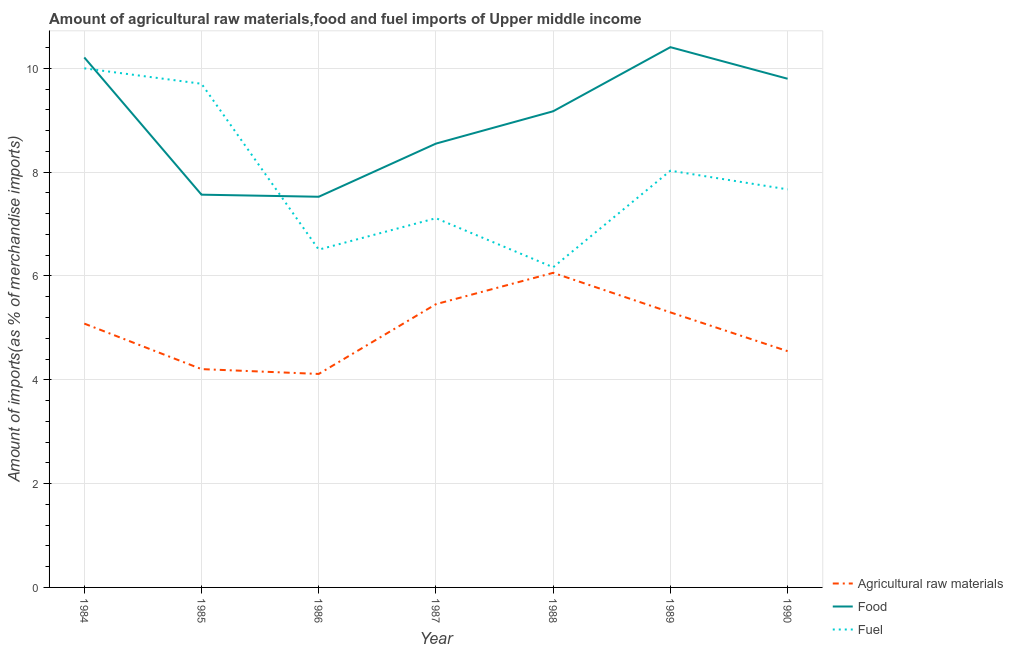Does the line corresponding to percentage of food imports intersect with the line corresponding to percentage of fuel imports?
Offer a terse response. Yes. What is the percentage of fuel imports in 1985?
Offer a terse response. 9.7. Across all years, what is the maximum percentage of food imports?
Offer a terse response. 10.41. Across all years, what is the minimum percentage of raw materials imports?
Your answer should be compact. 4.11. What is the total percentage of fuel imports in the graph?
Provide a short and direct response. 55.19. What is the difference between the percentage of raw materials imports in 1985 and that in 1990?
Give a very brief answer. -0.35. What is the difference between the percentage of fuel imports in 1988 and the percentage of raw materials imports in 1987?
Offer a very short reply. 0.71. What is the average percentage of food imports per year?
Your answer should be compact. 9.03. In the year 1990, what is the difference between the percentage of fuel imports and percentage of raw materials imports?
Your answer should be compact. 3.12. What is the ratio of the percentage of food imports in 1984 to that in 1986?
Ensure brevity in your answer.  1.36. What is the difference between the highest and the second highest percentage of fuel imports?
Offer a very short reply. 0.3. What is the difference between the highest and the lowest percentage of raw materials imports?
Your answer should be very brief. 1.95. Is the sum of the percentage of food imports in 1984 and 1988 greater than the maximum percentage of raw materials imports across all years?
Provide a short and direct response. Yes. Is it the case that in every year, the sum of the percentage of raw materials imports and percentage of food imports is greater than the percentage of fuel imports?
Keep it short and to the point. Yes. Is the percentage of raw materials imports strictly less than the percentage of fuel imports over the years?
Give a very brief answer. Yes. How many lines are there?
Give a very brief answer. 3. Where does the legend appear in the graph?
Provide a short and direct response. Bottom right. What is the title of the graph?
Your answer should be very brief. Amount of agricultural raw materials,food and fuel imports of Upper middle income. What is the label or title of the X-axis?
Keep it short and to the point. Year. What is the label or title of the Y-axis?
Your answer should be compact. Amount of imports(as % of merchandise imports). What is the Amount of imports(as % of merchandise imports) of Agricultural raw materials in 1984?
Give a very brief answer. 5.08. What is the Amount of imports(as % of merchandise imports) of Food in 1984?
Offer a terse response. 10.21. What is the Amount of imports(as % of merchandise imports) in Fuel in 1984?
Give a very brief answer. 10. What is the Amount of imports(as % of merchandise imports) in Agricultural raw materials in 1985?
Your answer should be compact. 4.21. What is the Amount of imports(as % of merchandise imports) in Food in 1985?
Give a very brief answer. 7.57. What is the Amount of imports(as % of merchandise imports) of Fuel in 1985?
Your answer should be compact. 9.7. What is the Amount of imports(as % of merchandise imports) in Agricultural raw materials in 1986?
Provide a succinct answer. 4.11. What is the Amount of imports(as % of merchandise imports) of Food in 1986?
Your response must be concise. 7.53. What is the Amount of imports(as % of merchandise imports) of Fuel in 1986?
Ensure brevity in your answer.  6.51. What is the Amount of imports(as % of merchandise imports) of Agricultural raw materials in 1987?
Keep it short and to the point. 5.46. What is the Amount of imports(as % of merchandise imports) in Food in 1987?
Ensure brevity in your answer.  8.55. What is the Amount of imports(as % of merchandise imports) of Fuel in 1987?
Your answer should be compact. 7.11. What is the Amount of imports(as % of merchandise imports) of Agricultural raw materials in 1988?
Your answer should be compact. 6.06. What is the Amount of imports(as % of merchandise imports) of Food in 1988?
Your answer should be very brief. 9.17. What is the Amount of imports(as % of merchandise imports) in Fuel in 1988?
Provide a succinct answer. 6.17. What is the Amount of imports(as % of merchandise imports) in Agricultural raw materials in 1989?
Your response must be concise. 5.3. What is the Amount of imports(as % of merchandise imports) in Food in 1989?
Provide a succinct answer. 10.41. What is the Amount of imports(as % of merchandise imports) of Fuel in 1989?
Your response must be concise. 8.03. What is the Amount of imports(as % of merchandise imports) in Agricultural raw materials in 1990?
Offer a terse response. 4.55. What is the Amount of imports(as % of merchandise imports) of Food in 1990?
Offer a terse response. 9.8. What is the Amount of imports(as % of merchandise imports) of Fuel in 1990?
Your response must be concise. 7.67. Across all years, what is the maximum Amount of imports(as % of merchandise imports) of Agricultural raw materials?
Provide a short and direct response. 6.06. Across all years, what is the maximum Amount of imports(as % of merchandise imports) in Food?
Your answer should be compact. 10.41. Across all years, what is the maximum Amount of imports(as % of merchandise imports) in Fuel?
Offer a very short reply. 10. Across all years, what is the minimum Amount of imports(as % of merchandise imports) in Agricultural raw materials?
Your response must be concise. 4.11. Across all years, what is the minimum Amount of imports(as % of merchandise imports) of Food?
Give a very brief answer. 7.53. Across all years, what is the minimum Amount of imports(as % of merchandise imports) in Fuel?
Give a very brief answer. 6.17. What is the total Amount of imports(as % of merchandise imports) of Agricultural raw materials in the graph?
Give a very brief answer. 34.77. What is the total Amount of imports(as % of merchandise imports) in Food in the graph?
Your answer should be compact. 63.23. What is the total Amount of imports(as % of merchandise imports) of Fuel in the graph?
Make the answer very short. 55.19. What is the difference between the Amount of imports(as % of merchandise imports) in Agricultural raw materials in 1984 and that in 1985?
Give a very brief answer. 0.88. What is the difference between the Amount of imports(as % of merchandise imports) of Food in 1984 and that in 1985?
Offer a terse response. 2.64. What is the difference between the Amount of imports(as % of merchandise imports) in Fuel in 1984 and that in 1985?
Provide a succinct answer. 0.3. What is the difference between the Amount of imports(as % of merchandise imports) in Agricultural raw materials in 1984 and that in 1986?
Your answer should be compact. 0.97. What is the difference between the Amount of imports(as % of merchandise imports) of Food in 1984 and that in 1986?
Provide a succinct answer. 2.68. What is the difference between the Amount of imports(as % of merchandise imports) in Fuel in 1984 and that in 1986?
Make the answer very short. 3.49. What is the difference between the Amount of imports(as % of merchandise imports) of Agricultural raw materials in 1984 and that in 1987?
Keep it short and to the point. -0.37. What is the difference between the Amount of imports(as % of merchandise imports) of Food in 1984 and that in 1987?
Keep it short and to the point. 1.66. What is the difference between the Amount of imports(as % of merchandise imports) of Fuel in 1984 and that in 1987?
Ensure brevity in your answer.  2.89. What is the difference between the Amount of imports(as % of merchandise imports) in Agricultural raw materials in 1984 and that in 1988?
Keep it short and to the point. -0.98. What is the difference between the Amount of imports(as % of merchandise imports) of Food in 1984 and that in 1988?
Provide a succinct answer. 1.04. What is the difference between the Amount of imports(as % of merchandise imports) of Fuel in 1984 and that in 1988?
Provide a short and direct response. 3.83. What is the difference between the Amount of imports(as % of merchandise imports) of Agricultural raw materials in 1984 and that in 1989?
Give a very brief answer. -0.22. What is the difference between the Amount of imports(as % of merchandise imports) in Food in 1984 and that in 1989?
Give a very brief answer. -0.2. What is the difference between the Amount of imports(as % of merchandise imports) in Fuel in 1984 and that in 1989?
Your answer should be compact. 1.97. What is the difference between the Amount of imports(as % of merchandise imports) of Agricultural raw materials in 1984 and that in 1990?
Your answer should be compact. 0.53. What is the difference between the Amount of imports(as % of merchandise imports) of Food in 1984 and that in 1990?
Ensure brevity in your answer.  0.41. What is the difference between the Amount of imports(as % of merchandise imports) in Fuel in 1984 and that in 1990?
Offer a terse response. 2.33. What is the difference between the Amount of imports(as % of merchandise imports) in Agricultural raw materials in 1985 and that in 1986?
Give a very brief answer. 0.09. What is the difference between the Amount of imports(as % of merchandise imports) of Food in 1985 and that in 1986?
Your response must be concise. 0.04. What is the difference between the Amount of imports(as % of merchandise imports) in Fuel in 1985 and that in 1986?
Provide a short and direct response. 3.2. What is the difference between the Amount of imports(as % of merchandise imports) in Agricultural raw materials in 1985 and that in 1987?
Make the answer very short. -1.25. What is the difference between the Amount of imports(as % of merchandise imports) in Food in 1985 and that in 1987?
Keep it short and to the point. -0.98. What is the difference between the Amount of imports(as % of merchandise imports) of Fuel in 1985 and that in 1987?
Provide a short and direct response. 2.59. What is the difference between the Amount of imports(as % of merchandise imports) of Agricultural raw materials in 1985 and that in 1988?
Your response must be concise. -1.85. What is the difference between the Amount of imports(as % of merchandise imports) of Food in 1985 and that in 1988?
Your answer should be compact. -1.61. What is the difference between the Amount of imports(as % of merchandise imports) in Fuel in 1985 and that in 1988?
Provide a short and direct response. 3.54. What is the difference between the Amount of imports(as % of merchandise imports) of Agricultural raw materials in 1985 and that in 1989?
Give a very brief answer. -1.09. What is the difference between the Amount of imports(as % of merchandise imports) in Food in 1985 and that in 1989?
Provide a short and direct response. -2.84. What is the difference between the Amount of imports(as % of merchandise imports) of Fuel in 1985 and that in 1989?
Give a very brief answer. 1.67. What is the difference between the Amount of imports(as % of merchandise imports) of Agricultural raw materials in 1985 and that in 1990?
Offer a very short reply. -0.35. What is the difference between the Amount of imports(as % of merchandise imports) of Food in 1985 and that in 1990?
Provide a succinct answer. -2.23. What is the difference between the Amount of imports(as % of merchandise imports) in Fuel in 1985 and that in 1990?
Make the answer very short. 2.03. What is the difference between the Amount of imports(as % of merchandise imports) of Agricultural raw materials in 1986 and that in 1987?
Keep it short and to the point. -1.34. What is the difference between the Amount of imports(as % of merchandise imports) in Food in 1986 and that in 1987?
Keep it short and to the point. -1.02. What is the difference between the Amount of imports(as % of merchandise imports) of Fuel in 1986 and that in 1987?
Keep it short and to the point. -0.61. What is the difference between the Amount of imports(as % of merchandise imports) of Agricultural raw materials in 1986 and that in 1988?
Your response must be concise. -1.95. What is the difference between the Amount of imports(as % of merchandise imports) in Food in 1986 and that in 1988?
Provide a succinct answer. -1.65. What is the difference between the Amount of imports(as % of merchandise imports) in Fuel in 1986 and that in 1988?
Offer a terse response. 0.34. What is the difference between the Amount of imports(as % of merchandise imports) in Agricultural raw materials in 1986 and that in 1989?
Your answer should be compact. -1.19. What is the difference between the Amount of imports(as % of merchandise imports) of Food in 1986 and that in 1989?
Provide a succinct answer. -2.88. What is the difference between the Amount of imports(as % of merchandise imports) in Fuel in 1986 and that in 1989?
Your response must be concise. -1.52. What is the difference between the Amount of imports(as % of merchandise imports) in Agricultural raw materials in 1986 and that in 1990?
Provide a succinct answer. -0.44. What is the difference between the Amount of imports(as % of merchandise imports) in Food in 1986 and that in 1990?
Your answer should be very brief. -2.27. What is the difference between the Amount of imports(as % of merchandise imports) of Fuel in 1986 and that in 1990?
Provide a succinct answer. -1.16. What is the difference between the Amount of imports(as % of merchandise imports) of Agricultural raw materials in 1987 and that in 1988?
Provide a short and direct response. -0.6. What is the difference between the Amount of imports(as % of merchandise imports) in Food in 1987 and that in 1988?
Give a very brief answer. -0.62. What is the difference between the Amount of imports(as % of merchandise imports) in Fuel in 1987 and that in 1988?
Your answer should be very brief. 0.95. What is the difference between the Amount of imports(as % of merchandise imports) in Agricultural raw materials in 1987 and that in 1989?
Make the answer very short. 0.16. What is the difference between the Amount of imports(as % of merchandise imports) of Food in 1987 and that in 1989?
Keep it short and to the point. -1.86. What is the difference between the Amount of imports(as % of merchandise imports) in Fuel in 1987 and that in 1989?
Provide a succinct answer. -0.92. What is the difference between the Amount of imports(as % of merchandise imports) of Agricultural raw materials in 1987 and that in 1990?
Your answer should be compact. 0.91. What is the difference between the Amount of imports(as % of merchandise imports) in Food in 1987 and that in 1990?
Provide a succinct answer. -1.25. What is the difference between the Amount of imports(as % of merchandise imports) of Fuel in 1987 and that in 1990?
Provide a short and direct response. -0.56. What is the difference between the Amount of imports(as % of merchandise imports) in Agricultural raw materials in 1988 and that in 1989?
Your answer should be compact. 0.76. What is the difference between the Amount of imports(as % of merchandise imports) of Food in 1988 and that in 1989?
Provide a short and direct response. -1.23. What is the difference between the Amount of imports(as % of merchandise imports) in Fuel in 1988 and that in 1989?
Your answer should be very brief. -1.86. What is the difference between the Amount of imports(as % of merchandise imports) of Agricultural raw materials in 1988 and that in 1990?
Offer a terse response. 1.51. What is the difference between the Amount of imports(as % of merchandise imports) in Food in 1988 and that in 1990?
Offer a very short reply. -0.63. What is the difference between the Amount of imports(as % of merchandise imports) of Fuel in 1988 and that in 1990?
Your response must be concise. -1.5. What is the difference between the Amount of imports(as % of merchandise imports) of Agricultural raw materials in 1989 and that in 1990?
Keep it short and to the point. 0.75. What is the difference between the Amount of imports(as % of merchandise imports) in Food in 1989 and that in 1990?
Give a very brief answer. 0.61. What is the difference between the Amount of imports(as % of merchandise imports) in Fuel in 1989 and that in 1990?
Provide a succinct answer. 0.36. What is the difference between the Amount of imports(as % of merchandise imports) in Agricultural raw materials in 1984 and the Amount of imports(as % of merchandise imports) in Food in 1985?
Keep it short and to the point. -2.48. What is the difference between the Amount of imports(as % of merchandise imports) in Agricultural raw materials in 1984 and the Amount of imports(as % of merchandise imports) in Fuel in 1985?
Provide a short and direct response. -4.62. What is the difference between the Amount of imports(as % of merchandise imports) of Food in 1984 and the Amount of imports(as % of merchandise imports) of Fuel in 1985?
Provide a succinct answer. 0.51. What is the difference between the Amount of imports(as % of merchandise imports) in Agricultural raw materials in 1984 and the Amount of imports(as % of merchandise imports) in Food in 1986?
Make the answer very short. -2.44. What is the difference between the Amount of imports(as % of merchandise imports) in Agricultural raw materials in 1984 and the Amount of imports(as % of merchandise imports) in Fuel in 1986?
Offer a very short reply. -1.42. What is the difference between the Amount of imports(as % of merchandise imports) in Food in 1984 and the Amount of imports(as % of merchandise imports) in Fuel in 1986?
Keep it short and to the point. 3.7. What is the difference between the Amount of imports(as % of merchandise imports) in Agricultural raw materials in 1984 and the Amount of imports(as % of merchandise imports) in Food in 1987?
Provide a succinct answer. -3.47. What is the difference between the Amount of imports(as % of merchandise imports) of Agricultural raw materials in 1984 and the Amount of imports(as % of merchandise imports) of Fuel in 1987?
Ensure brevity in your answer.  -2.03. What is the difference between the Amount of imports(as % of merchandise imports) of Food in 1984 and the Amount of imports(as % of merchandise imports) of Fuel in 1987?
Offer a terse response. 3.1. What is the difference between the Amount of imports(as % of merchandise imports) of Agricultural raw materials in 1984 and the Amount of imports(as % of merchandise imports) of Food in 1988?
Provide a succinct answer. -4.09. What is the difference between the Amount of imports(as % of merchandise imports) of Agricultural raw materials in 1984 and the Amount of imports(as % of merchandise imports) of Fuel in 1988?
Give a very brief answer. -1.08. What is the difference between the Amount of imports(as % of merchandise imports) of Food in 1984 and the Amount of imports(as % of merchandise imports) of Fuel in 1988?
Offer a terse response. 4.04. What is the difference between the Amount of imports(as % of merchandise imports) of Agricultural raw materials in 1984 and the Amount of imports(as % of merchandise imports) of Food in 1989?
Your response must be concise. -5.33. What is the difference between the Amount of imports(as % of merchandise imports) of Agricultural raw materials in 1984 and the Amount of imports(as % of merchandise imports) of Fuel in 1989?
Offer a very short reply. -2.95. What is the difference between the Amount of imports(as % of merchandise imports) in Food in 1984 and the Amount of imports(as % of merchandise imports) in Fuel in 1989?
Your response must be concise. 2.18. What is the difference between the Amount of imports(as % of merchandise imports) in Agricultural raw materials in 1984 and the Amount of imports(as % of merchandise imports) in Food in 1990?
Keep it short and to the point. -4.72. What is the difference between the Amount of imports(as % of merchandise imports) in Agricultural raw materials in 1984 and the Amount of imports(as % of merchandise imports) in Fuel in 1990?
Offer a terse response. -2.59. What is the difference between the Amount of imports(as % of merchandise imports) in Food in 1984 and the Amount of imports(as % of merchandise imports) in Fuel in 1990?
Offer a terse response. 2.54. What is the difference between the Amount of imports(as % of merchandise imports) in Agricultural raw materials in 1985 and the Amount of imports(as % of merchandise imports) in Food in 1986?
Offer a very short reply. -3.32. What is the difference between the Amount of imports(as % of merchandise imports) of Agricultural raw materials in 1985 and the Amount of imports(as % of merchandise imports) of Fuel in 1986?
Keep it short and to the point. -2.3. What is the difference between the Amount of imports(as % of merchandise imports) of Food in 1985 and the Amount of imports(as % of merchandise imports) of Fuel in 1986?
Ensure brevity in your answer.  1.06. What is the difference between the Amount of imports(as % of merchandise imports) of Agricultural raw materials in 1985 and the Amount of imports(as % of merchandise imports) of Food in 1987?
Offer a terse response. -4.34. What is the difference between the Amount of imports(as % of merchandise imports) in Agricultural raw materials in 1985 and the Amount of imports(as % of merchandise imports) in Fuel in 1987?
Give a very brief answer. -2.91. What is the difference between the Amount of imports(as % of merchandise imports) in Food in 1985 and the Amount of imports(as % of merchandise imports) in Fuel in 1987?
Provide a succinct answer. 0.45. What is the difference between the Amount of imports(as % of merchandise imports) of Agricultural raw materials in 1985 and the Amount of imports(as % of merchandise imports) of Food in 1988?
Give a very brief answer. -4.97. What is the difference between the Amount of imports(as % of merchandise imports) in Agricultural raw materials in 1985 and the Amount of imports(as % of merchandise imports) in Fuel in 1988?
Ensure brevity in your answer.  -1.96. What is the difference between the Amount of imports(as % of merchandise imports) in Food in 1985 and the Amount of imports(as % of merchandise imports) in Fuel in 1988?
Your answer should be very brief. 1.4. What is the difference between the Amount of imports(as % of merchandise imports) of Agricultural raw materials in 1985 and the Amount of imports(as % of merchandise imports) of Food in 1989?
Give a very brief answer. -6.2. What is the difference between the Amount of imports(as % of merchandise imports) in Agricultural raw materials in 1985 and the Amount of imports(as % of merchandise imports) in Fuel in 1989?
Keep it short and to the point. -3.82. What is the difference between the Amount of imports(as % of merchandise imports) of Food in 1985 and the Amount of imports(as % of merchandise imports) of Fuel in 1989?
Offer a terse response. -0.46. What is the difference between the Amount of imports(as % of merchandise imports) of Agricultural raw materials in 1985 and the Amount of imports(as % of merchandise imports) of Food in 1990?
Give a very brief answer. -5.59. What is the difference between the Amount of imports(as % of merchandise imports) in Agricultural raw materials in 1985 and the Amount of imports(as % of merchandise imports) in Fuel in 1990?
Ensure brevity in your answer.  -3.46. What is the difference between the Amount of imports(as % of merchandise imports) of Food in 1985 and the Amount of imports(as % of merchandise imports) of Fuel in 1990?
Provide a short and direct response. -0.1. What is the difference between the Amount of imports(as % of merchandise imports) in Agricultural raw materials in 1986 and the Amount of imports(as % of merchandise imports) in Food in 1987?
Provide a succinct answer. -4.44. What is the difference between the Amount of imports(as % of merchandise imports) of Agricultural raw materials in 1986 and the Amount of imports(as % of merchandise imports) of Fuel in 1987?
Make the answer very short. -3. What is the difference between the Amount of imports(as % of merchandise imports) in Food in 1986 and the Amount of imports(as % of merchandise imports) in Fuel in 1987?
Ensure brevity in your answer.  0.41. What is the difference between the Amount of imports(as % of merchandise imports) of Agricultural raw materials in 1986 and the Amount of imports(as % of merchandise imports) of Food in 1988?
Your answer should be compact. -5.06. What is the difference between the Amount of imports(as % of merchandise imports) of Agricultural raw materials in 1986 and the Amount of imports(as % of merchandise imports) of Fuel in 1988?
Your response must be concise. -2.05. What is the difference between the Amount of imports(as % of merchandise imports) of Food in 1986 and the Amount of imports(as % of merchandise imports) of Fuel in 1988?
Keep it short and to the point. 1.36. What is the difference between the Amount of imports(as % of merchandise imports) of Agricultural raw materials in 1986 and the Amount of imports(as % of merchandise imports) of Food in 1989?
Make the answer very short. -6.3. What is the difference between the Amount of imports(as % of merchandise imports) in Agricultural raw materials in 1986 and the Amount of imports(as % of merchandise imports) in Fuel in 1989?
Provide a succinct answer. -3.92. What is the difference between the Amount of imports(as % of merchandise imports) of Food in 1986 and the Amount of imports(as % of merchandise imports) of Fuel in 1989?
Make the answer very short. -0.5. What is the difference between the Amount of imports(as % of merchandise imports) in Agricultural raw materials in 1986 and the Amount of imports(as % of merchandise imports) in Food in 1990?
Your answer should be compact. -5.69. What is the difference between the Amount of imports(as % of merchandise imports) of Agricultural raw materials in 1986 and the Amount of imports(as % of merchandise imports) of Fuel in 1990?
Your response must be concise. -3.56. What is the difference between the Amount of imports(as % of merchandise imports) in Food in 1986 and the Amount of imports(as % of merchandise imports) in Fuel in 1990?
Offer a terse response. -0.14. What is the difference between the Amount of imports(as % of merchandise imports) of Agricultural raw materials in 1987 and the Amount of imports(as % of merchandise imports) of Food in 1988?
Ensure brevity in your answer.  -3.72. What is the difference between the Amount of imports(as % of merchandise imports) in Agricultural raw materials in 1987 and the Amount of imports(as % of merchandise imports) in Fuel in 1988?
Provide a succinct answer. -0.71. What is the difference between the Amount of imports(as % of merchandise imports) in Food in 1987 and the Amount of imports(as % of merchandise imports) in Fuel in 1988?
Give a very brief answer. 2.38. What is the difference between the Amount of imports(as % of merchandise imports) of Agricultural raw materials in 1987 and the Amount of imports(as % of merchandise imports) of Food in 1989?
Ensure brevity in your answer.  -4.95. What is the difference between the Amount of imports(as % of merchandise imports) in Agricultural raw materials in 1987 and the Amount of imports(as % of merchandise imports) in Fuel in 1989?
Offer a terse response. -2.57. What is the difference between the Amount of imports(as % of merchandise imports) of Food in 1987 and the Amount of imports(as % of merchandise imports) of Fuel in 1989?
Offer a terse response. 0.52. What is the difference between the Amount of imports(as % of merchandise imports) in Agricultural raw materials in 1987 and the Amount of imports(as % of merchandise imports) in Food in 1990?
Your answer should be compact. -4.34. What is the difference between the Amount of imports(as % of merchandise imports) in Agricultural raw materials in 1987 and the Amount of imports(as % of merchandise imports) in Fuel in 1990?
Offer a very short reply. -2.21. What is the difference between the Amount of imports(as % of merchandise imports) of Food in 1987 and the Amount of imports(as % of merchandise imports) of Fuel in 1990?
Make the answer very short. 0.88. What is the difference between the Amount of imports(as % of merchandise imports) in Agricultural raw materials in 1988 and the Amount of imports(as % of merchandise imports) in Food in 1989?
Keep it short and to the point. -4.35. What is the difference between the Amount of imports(as % of merchandise imports) in Agricultural raw materials in 1988 and the Amount of imports(as % of merchandise imports) in Fuel in 1989?
Keep it short and to the point. -1.97. What is the difference between the Amount of imports(as % of merchandise imports) in Food in 1988 and the Amount of imports(as % of merchandise imports) in Fuel in 1989?
Offer a very short reply. 1.14. What is the difference between the Amount of imports(as % of merchandise imports) of Agricultural raw materials in 1988 and the Amount of imports(as % of merchandise imports) of Food in 1990?
Your response must be concise. -3.74. What is the difference between the Amount of imports(as % of merchandise imports) in Agricultural raw materials in 1988 and the Amount of imports(as % of merchandise imports) in Fuel in 1990?
Make the answer very short. -1.61. What is the difference between the Amount of imports(as % of merchandise imports) of Food in 1988 and the Amount of imports(as % of merchandise imports) of Fuel in 1990?
Your answer should be compact. 1.5. What is the difference between the Amount of imports(as % of merchandise imports) in Agricultural raw materials in 1989 and the Amount of imports(as % of merchandise imports) in Food in 1990?
Offer a terse response. -4.5. What is the difference between the Amount of imports(as % of merchandise imports) of Agricultural raw materials in 1989 and the Amount of imports(as % of merchandise imports) of Fuel in 1990?
Offer a terse response. -2.37. What is the difference between the Amount of imports(as % of merchandise imports) of Food in 1989 and the Amount of imports(as % of merchandise imports) of Fuel in 1990?
Your answer should be compact. 2.74. What is the average Amount of imports(as % of merchandise imports) of Agricultural raw materials per year?
Your answer should be very brief. 4.97. What is the average Amount of imports(as % of merchandise imports) of Food per year?
Provide a succinct answer. 9.03. What is the average Amount of imports(as % of merchandise imports) of Fuel per year?
Make the answer very short. 7.88. In the year 1984, what is the difference between the Amount of imports(as % of merchandise imports) of Agricultural raw materials and Amount of imports(as % of merchandise imports) of Food?
Offer a very short reply. -5.13. In the year 1984, what is the difference between the Amount of imports(as % of merchandise imports) of Agricultural raw materials and Amount of imports(as % of merchandise imports) of Fuel?
Offer a very short reply. -4.92. In the year 1984, what is the difference between the Amount of imports(as % of merchandise imports) of Food and Amount of imports(as % of merchandise imports) of Fuel?
Give a very brief answer. 0.21. In the year 1985, what is the difference between the Amount of imports(as % of merchandise imports) in Agricultural raw materials and Amount of imports(as % of merchandise imports) in Food?
Offer a very short reply. -3.36. In the year 1985, what is the difference between the Amount of imports(as % of merchandise imports) of Agricultural raw materials and Amount of imports(as % of merchandise imports) of Fuel?
Give a very brief answer. -5.5. In the year 1985, what is the difference between the Amount of imports(as % of merchandise imports) of Food and Amount of imports(as % of merchandise imports) of Fuel?
Your answer should be very brief. -2.14. In the year 1986, what is the difference between the Amount of imports(as % of merchandise imports) in Agricultural raw materials and Amount of imports(as % of merchandise imports) in Food?
Make the answer very short. -3.41. In the year 1986, what is the difference between the Amount of imports(as % of merchandise imports) in Agricultural raw materials and Amount of imports(as % of merchandise imports) in Fuel?
Offer a very short reply. -2.39. In the year 1986, what is the difference between the Amount of imports(as % of merchandise imports) of Food and Amount of imports(as % of merchandise imports) of Fuel?
Ensure brevity in your answer.  1.02. In the year 1987, what is the difference between the Amount of imports(as % of merchandise imports) of Agricultural raw materials and Amount of imports(as % of merchandise imports) of Food?
Your answer should be very brief. -3.09. In the year 1987, what is the difference between the Amount of imports(as % of merchandise imports) of Agricultural raw materials and Amount of imports(as % of merchandise imports) of Fuel?
Your answer should be very brief. -1.66. In the year 1987, what is the difference between the Amount of imports(as % of merchandise imports) of Food and Amount of imports(as % of merchandise imports) of Fuel?
Keep it short and to the point. 1.44. In the year 1988, what is the difference between the Amount of imports(as % of merchandise imports) in Agricultural raw materials and Amount of imports(as % of merchandise imports) in Food?
Give a very brief answer. -3.11. In the year 1988, what is the difference between the Amount of imports(as % of merchandise imports) of Agricultural raw materials and Amount of imports(as % of merchandise imports) of Fuel?
Give a very brief answer. -0.11. In the year 1988, what is the difference between the Amount of imports(as % of merchandise imports) of Food and Amount of imports(as % of merchandise imports) of Fuel?
Your answer should be very brief. 3.01. In the year 1989, what is the difference between the Amount of imports(as % of merchandise imports) of Agricultural raw materials and Amount of imports(as % of merchandise imports) of Food?
Ensure brevity in your answer.  -5.11. In the year 1989, what is the difference between the Amount of imports(as % of merchandise imports) of Agricultural raw materials and Amount of imports(as % of merchandise imports) of Fuel?
Provide a short and direct response. -2.73. In the year 1989, what is the difference between the Amount of imports(as % of merchandise imports) in Food and Amount of imports(as % of merchandise imports) in Fuel?
Give a very brief answer. 2.38. In the year 1990, what is the difference between the Amount of imports(as % of merchandise imports) of Agricultural raw materials and Amount of imports(as % of merchandise imports) of Food?
Your response must be concise. -5.25. In the year 1990, what is the difference between the Amount of imports(as % of merchandise imports) of Agricultural raw materials and Amount of imports(as % of merchandise imports) of Fuel?
Keep it short and to the point. -3.12. In the year 1990, what is the difference between the Amount of imports(as % of merchandise imports) in Food and Amount of imports(as % of merchandise imports) in Fuel?
Provide a short and direct response. 2.13. What is the ratio of the Amount of imports(as % of merchandise imports) of Agricultural raw materials in 1984 to that in 1985?
Provide a succinct answer. 1.21. What is the ratio of the Amount of imports(as % of merchandise imports) in Food in 1984 to that in 1985?
Offer a terse response. 1.35. What is the ratio of the Amount of imports(as % of merchandise imports) in Fuel in 1984 to that in 1985?
Make the answer very short. 1.03. What is the ratio of the Amount of imports(as % of merchandise imports) of Agricultural raw materials in 1984 to that in 1986?
Your response must be concise. 1.24. What is the ratio of the Amount of imports(as % of merchandise imports) of Food in 1984 to that in 1986?
Offer a very short reply. 1.36. What is the ratio of the Amount of imports(as % of merchandise imports) of Fuel in 1984 to that in 1986?
Your response must be concise. 1.54. What is the ratio of the Amount of imports(as % of merchandise imports) in Agricultural raw materials in 1984 to that in 1987?
Provide a succinct answer. 0.93. What is the ratio of the Amount of imports(as % of merchandise imports) in Food in 1984 to that in 1987?
Your answer should be compact. 1.19. What is the ratio of the Amount of imports(as % of merchandise imports) in Fuel in 1984 to that in 1987?
Ensure brevity in your answer.  1.41. What is the ratio of the Amount of imports(as % of merchandise imports) of Agricultural raw materials in 1984 to that in 1988?
Offer a very short reply. 0.84. What is the ratio of the Amount of imports(as % of merchandise imports) of Food in 1984 to that in 1988?
Your answer should be very brief. 1.11. What is the ratio of the Amount of imports(as % of merchandise imports) of Fuel in 1984 to that in 1988?
Your answer should be very brief. 1.62. What is the ratio of the Amount of imports(as % of merchandise imports) of Agricultural raw materials in 1984 to that in 1989?
Provide a succinct answer. 0.96. What is the ratio of the Amount of imports(as % of merchandise imports) of Food in 1984 to that in 1989?
Offer a very short reply. 0.98. What is the ratio of the Amount of imports(as % of merchandise imports) of Fuel in 1984 to that in 1989?
Give a very brief answer. 1.25. What is the ratio of the Amount of imports(as % of merchandise imports) in Agricultural raw materials in 1984 to that in 1990?
Provide a short and direct response. 1.12. What is the ratio of the Amount of imports(as % of merchandise imports) of Food in 1984 to that in 1990?
Offer a terse response. 1.04. What is the ratio of the Amount of imports(as % of merchandise imports) in Fuel in 1984 to that in 1990?
Your answer should be very brief. 1.3. What is the ratio of the Amount of imports(as % of merchandise imports) in Agricultural raw materials in 1985 to that in 1986?
Provide a short and direct response. 1.02. What is the ratio of the Amount of imports(as % of merchandise imports) in Food in 1985 to that in 1986?
Your answer should be very brief. 1.01. What is the ratio of the Amount of imports(as % of merchandise imports) in Fuel in 1985 to that in 1986?
Offer a very short reply. 1.49. What is the ratio of the Amount of imports(as % of merchandise imports) in Agricultural raw materials in 1985 to that in 1987?
Give a very brief answer. 0.77. What is the ratio of the Amount of imports(as % of merchandise imports) of Food in 1985 to that in 1987?
Provide a short and direct response. 0.88. What is the ratio of the Amount of imports(as % of merchandise imports) in Fuel in 1985 to that in 1987?
Your answer should be very brief. 1.36. What is the ratio of the Amount of imports(as % of merchandise imports) of Agricultural raw materials in 1985 to that in 1988?
Ensure brevity in your answer.  0.69. What is the ratio of the Amount of imports(as % of merchandise imports) in Food in 1985 to that in 1988?
Offer a very short reply. 0.82. What is the ratio of the Amount of imports(as % of merchandise imports) in Fuel in 1985 to that in 1988?
Offer a terse response. 1.57. What is the ratio of the Amount of imports(as % of merchandise imports) of Agricultural raw materials in 1985 to that in 1989?
Your answer should be compact. 0.79. What is the ratio of the Amount of imports(as % of merchandise imports) of Food in 1985 to that in 1989?
Provide a succinct answer. 0.73. What is the ratio of the Amount of imports(as % of merchandise imports) in Fuel in 1985 to that in 1989?
Keep it short and to the point. 1.21. What is the ratio of the Amount of imports(as % of merchandise imports) of Agricultural raw materials in 1985 to that in 1990?
Offer a very short reply. 0.92. What is the ratio of the Amount of imports(as % of merchandise imports) in Food in 1985 to that in 1990?
Ensure brevity in your answer.  0.77. What is the ratio of the Amount of imports(as % of merchandise imports) of Fuel in 1985 to that in 1990?
Provide a short and direct response. 1.27. What is the ratio of the Amount of imports(as % of merchandise imports) of Agricultural raw materials in 1986 to that in 1987?
Keep it short and to the point. 0.75. What is the ratio of the Amount of imports(as % of merchandise imports) in Food in 1986 to that in 1987?
Your answer should be very brief. 0.88. What is the ratio of the Amount of imports(as % of merchandise imports) of Fuel in 1986 to that in 1987?
Provide a short and direct response. 0.91. What is the ratio of the Amount of imports(as % of merchandise imports) of Agricultural raw materials in 1986 to that in 1988?
Offer a very short reply. 0.68. What is the ratio of the Amount of imports(as % of merchandise imports) in Food in 1986 to that in 1988?
Give a very brief answer. 0.82. What is the ratio of the Amount of imports(as % of merchandise imports) in Fuel in 1986 to that in 1988?
Ensure brevity in your answer.  1.06. What is the ratio of the Amount of imports(as % of merchandise imports) of Agricultural raw materials in 1986 to that in 1989?
Your answer should be compact. 0.78. What is the ratio of the Amount of imports(as % of merchandise imports) of Food in 1986 to that in 1989?
Your response must be concise. 0.72. What is the ratio of the Amount of imports(as % of merchandise imports) in Fuel in 1986 to that in 1989?
Ensure brevity in your answer.  0.81. What is the ratio of the Amount of imports(as % of merchandise imports) in Agricultural raw materials in 1986 to that in 1990?
Provide a short and direct response. 0.9. What is the ratio of the Amount of imports(as % of merchandise imports) in Food in 1986 to that in 1990?
Your response must be concise. 0.77. What is the ratio of the Amount of imports(as % of merchandise imports) in Fuel in 1986 to that in 1990?
Make the answer very short. 0.85. What is the ratio of the Amount of imports(as % of merchandise imports) of Agricultural raw materials in 1987 to that in 1988?
Keep it short and to the point. 0.9. What is the ratio of the Amount of imports(as % of merchandise imports) of Food in 1987 to that in 1988?
Keep it short and to the point. 0.93. What is the ratio of the Amount of imports(as % of merchandise imports) in Fuel in 1987 to that in 1988?
Ensure brevity in your answer.  1.15. What is the ratio of the Amount of imports(as % of merchandise imports) of Agricultural raw materials in 1987 to that in 1989?
Offer a terse response. 1.03. What is the ratio of the Amount of imports(as % of merchandise imports) in Food in 1987 to that in 1989?
Provide a short and direct response. 0.82. What is the ratio of the Amount of imports(as % of merchandise imports) in Fuel in 1987 to that in 1989?
Your answer should be very brief. 0.89. What is the ratio of the Amount of imports(as % of merchandise imports) of Agricultural raw materials in 1987 to that in 1990?
Your answer should be very brief. 1.2. What is the ratio of the Amount of imports(as % of merchandise imports) of Food in 1987 to that in 1990?
Ensure brevity in your answer.  0.87. What is the ratio of the Amount of imports(as % of merchandise imports) of Fuel in 1987 to that in 1990?
Offer a very short reply. 0.93. What is the ratio of the Amount of imports(as % of merchandise imports) in Agricultural raw materials in 1988 to that in 1989?
Provide a short and direct response. 1.14. What is the ratio of the Amount of imports(as % of merchandise imports) of Food in 1988 to that in 1989?
Offer a terse response. 0.88. What is the ratio of the Amount of imports(as % of merchandise imports) of Fuel in 1988 to that in 1989?
Provide a short and direct response. 0.77. What is the ratio of the Amount of imports(as % of merchandise imports) in Agricultural raw materials in 1988 to that in 1990?
Provide a short and direct response. 1.33. What is the ratio of the Amount of imports(as % of merchandise imports) in Food in 1988 to that in 1990?
Your answer should be very brief. 0.94. What is the ratio of the Amount of imports(as % of merchandise imports) in Fuel in 1988 to that in 1990?
Provide a succinct answer. 0.8. What is the ratio of the Amount of imports(as % of merchandise imports) of Agricultural raw materials in 1989 to that in 1990?
Make the answer very short. 1.16. What is the ratio of the Amount of imports(as % of merchandise imports) of Food in 1989 to that in 1990?
Offer a terse response. 1.06. What is the ratio of the Amount of imports(as % of merchandise imports) in Fuel in 1989 to that in 1990?
Your answer should be very brief. 1.05. What is the difference between the highest and the second highest Amount of imports(as % of merchandise imports) of Agricultural raw materials?
Provide a short and direct response. 0.6. What is the difference between the highest and the second highest Amount of imports(as % of merchandise imports) of Food?
Make the answer very short. 0.2. What is the difference between the highest and the second highest Amount of imports(as % of merchandise imports) of Fuel?
Give a very brief answer. 0.3. What is the difference between the highest and the lowest Amount of imports(as % of merchandise imports) in Agricultural raw materials?
Make the answer very short. 1.95. What is the difference between the highest and the lowest Amount of imports(as % of merchandise imports) of Food?
Provide a succinct answer. 2.88. What is the difference between the highest and the lowest Amount of imports(as % of merchandise imports) in Fuel?
Make the answer very short. 3.83. 